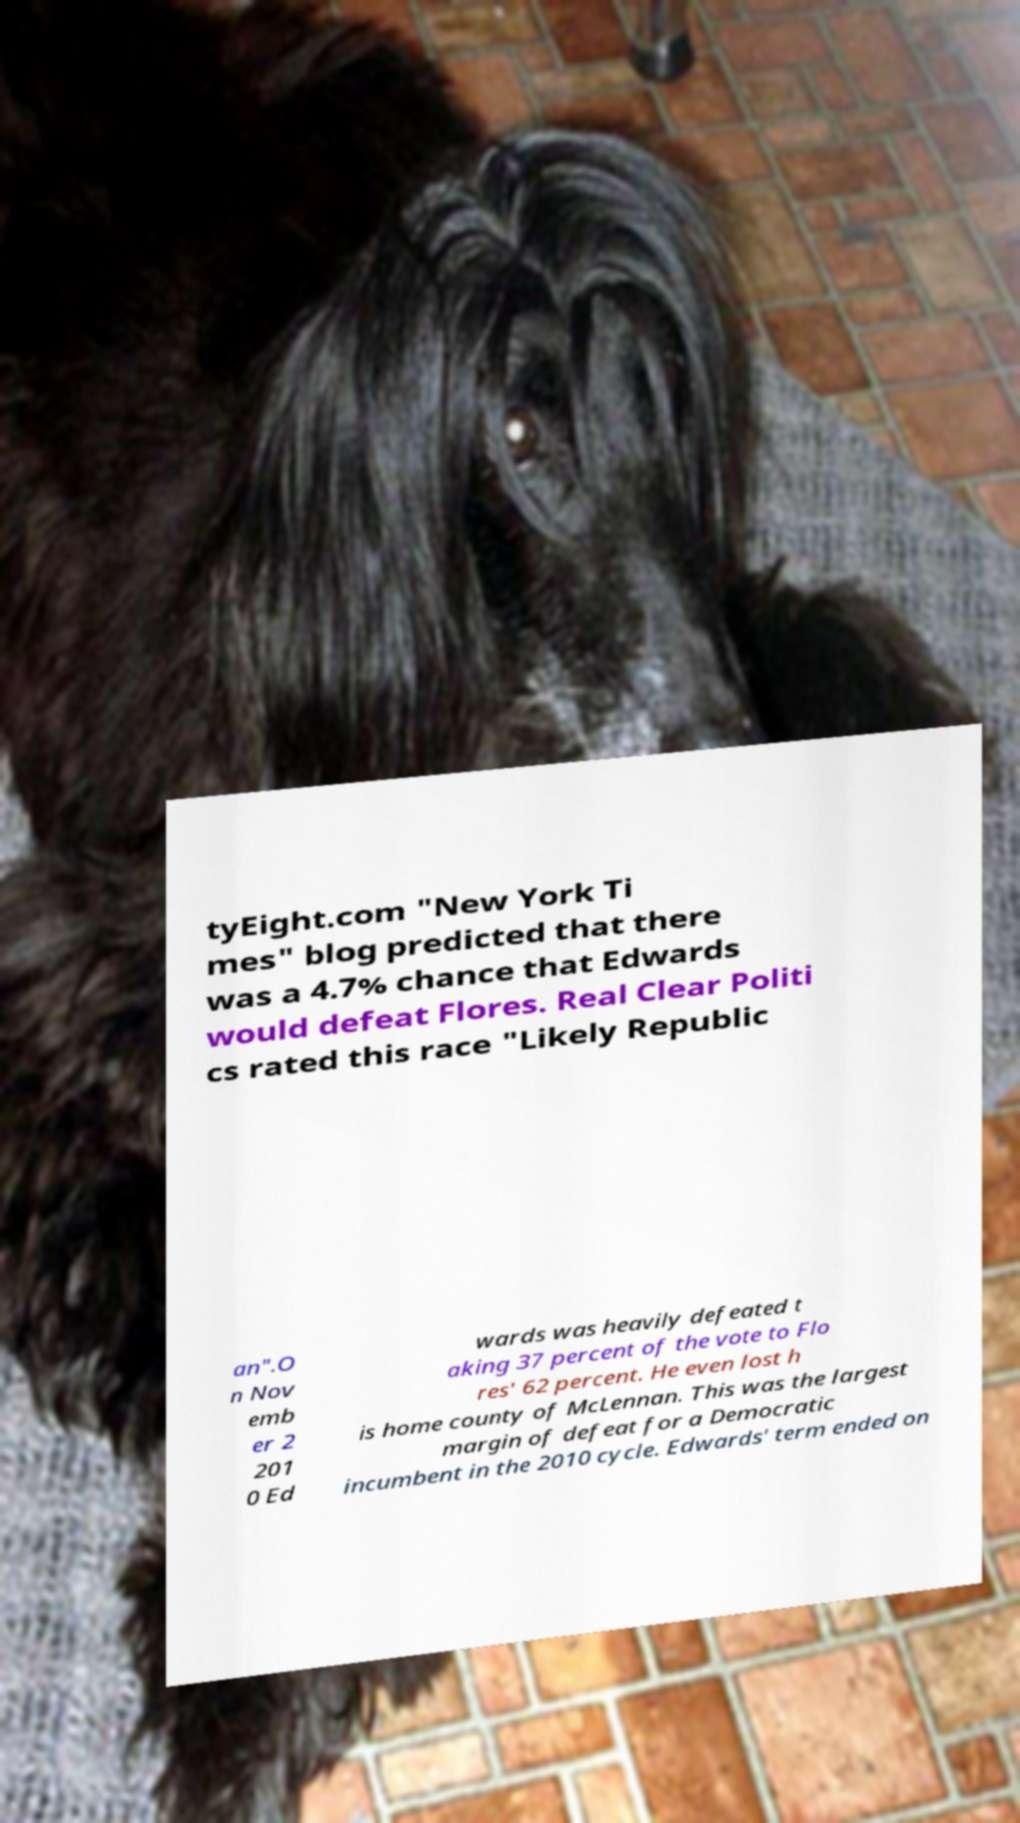Please read and relay the text visible in this image. What does it say? tyEight.com "New York Ti mes" blog predicted that there was a 4.7% chance that Edwards would defeat Flores. Real Clear Politi cs rated this race "Likely Republic an".O n Nov emb er 2 201 0 Ed wards was heavily defeated t aking 37 percent of the vote to Flo res' 62 percent. He even lost h is home county of McLennan. This was the largest margin of defeat for a Democratic incumbent in the 2010 cycle. Edwards' term ended on 